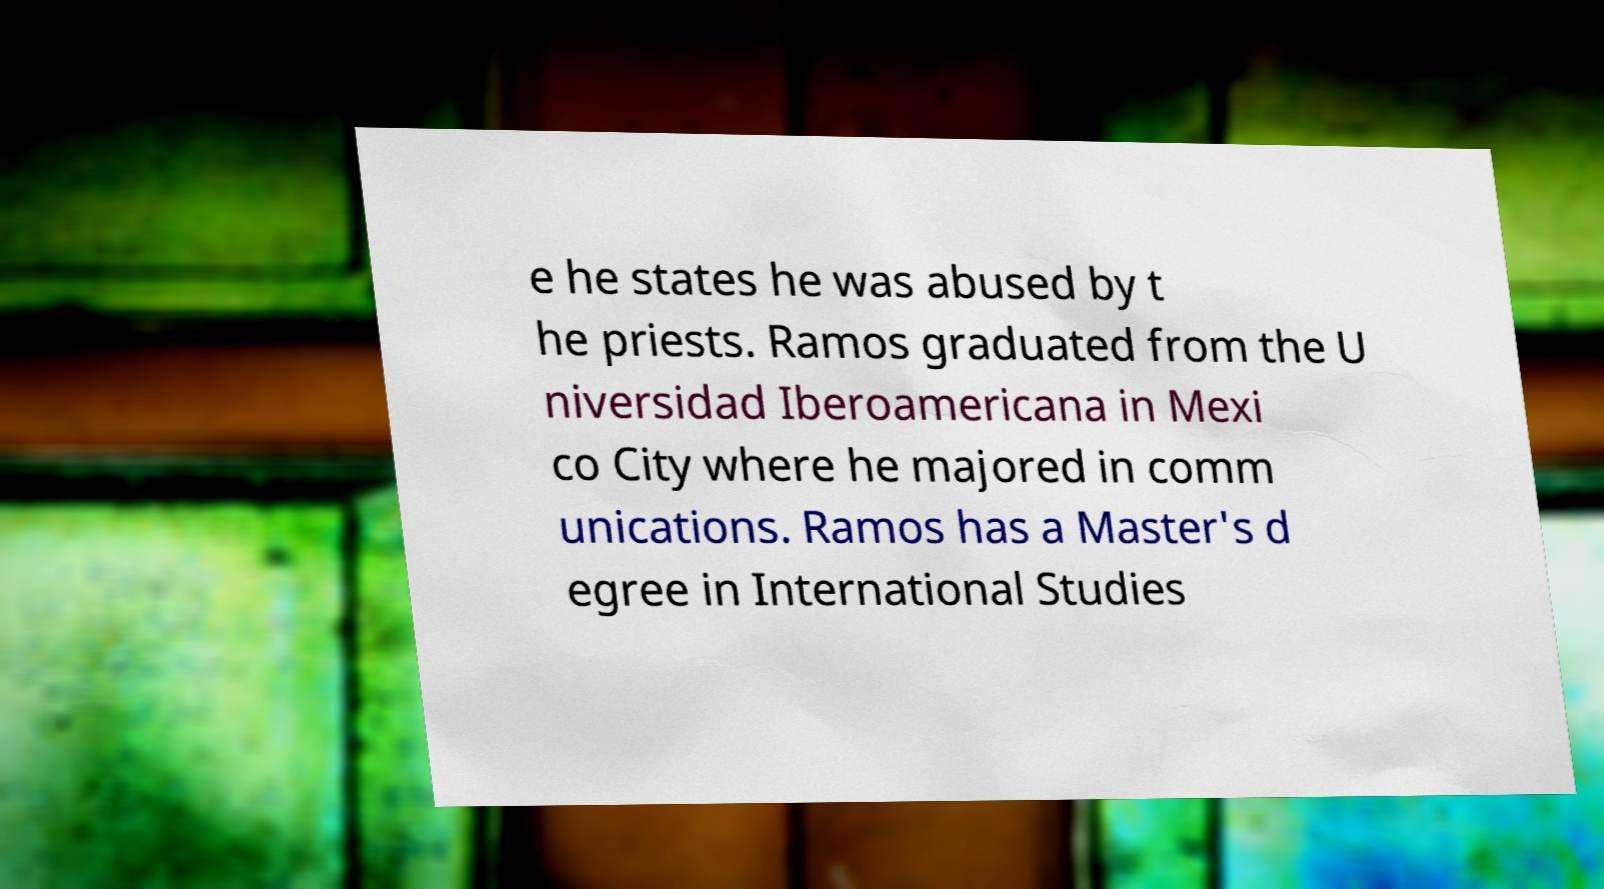What messages or text are displayed in this image? I need them in a readable, typed format. e he states he was abused by t he priests. Ramos graduated from the U niversidad Iberoamericana in Mexi co City where he majored in comm unications. Ramos has a Master's d egree in International Studies 